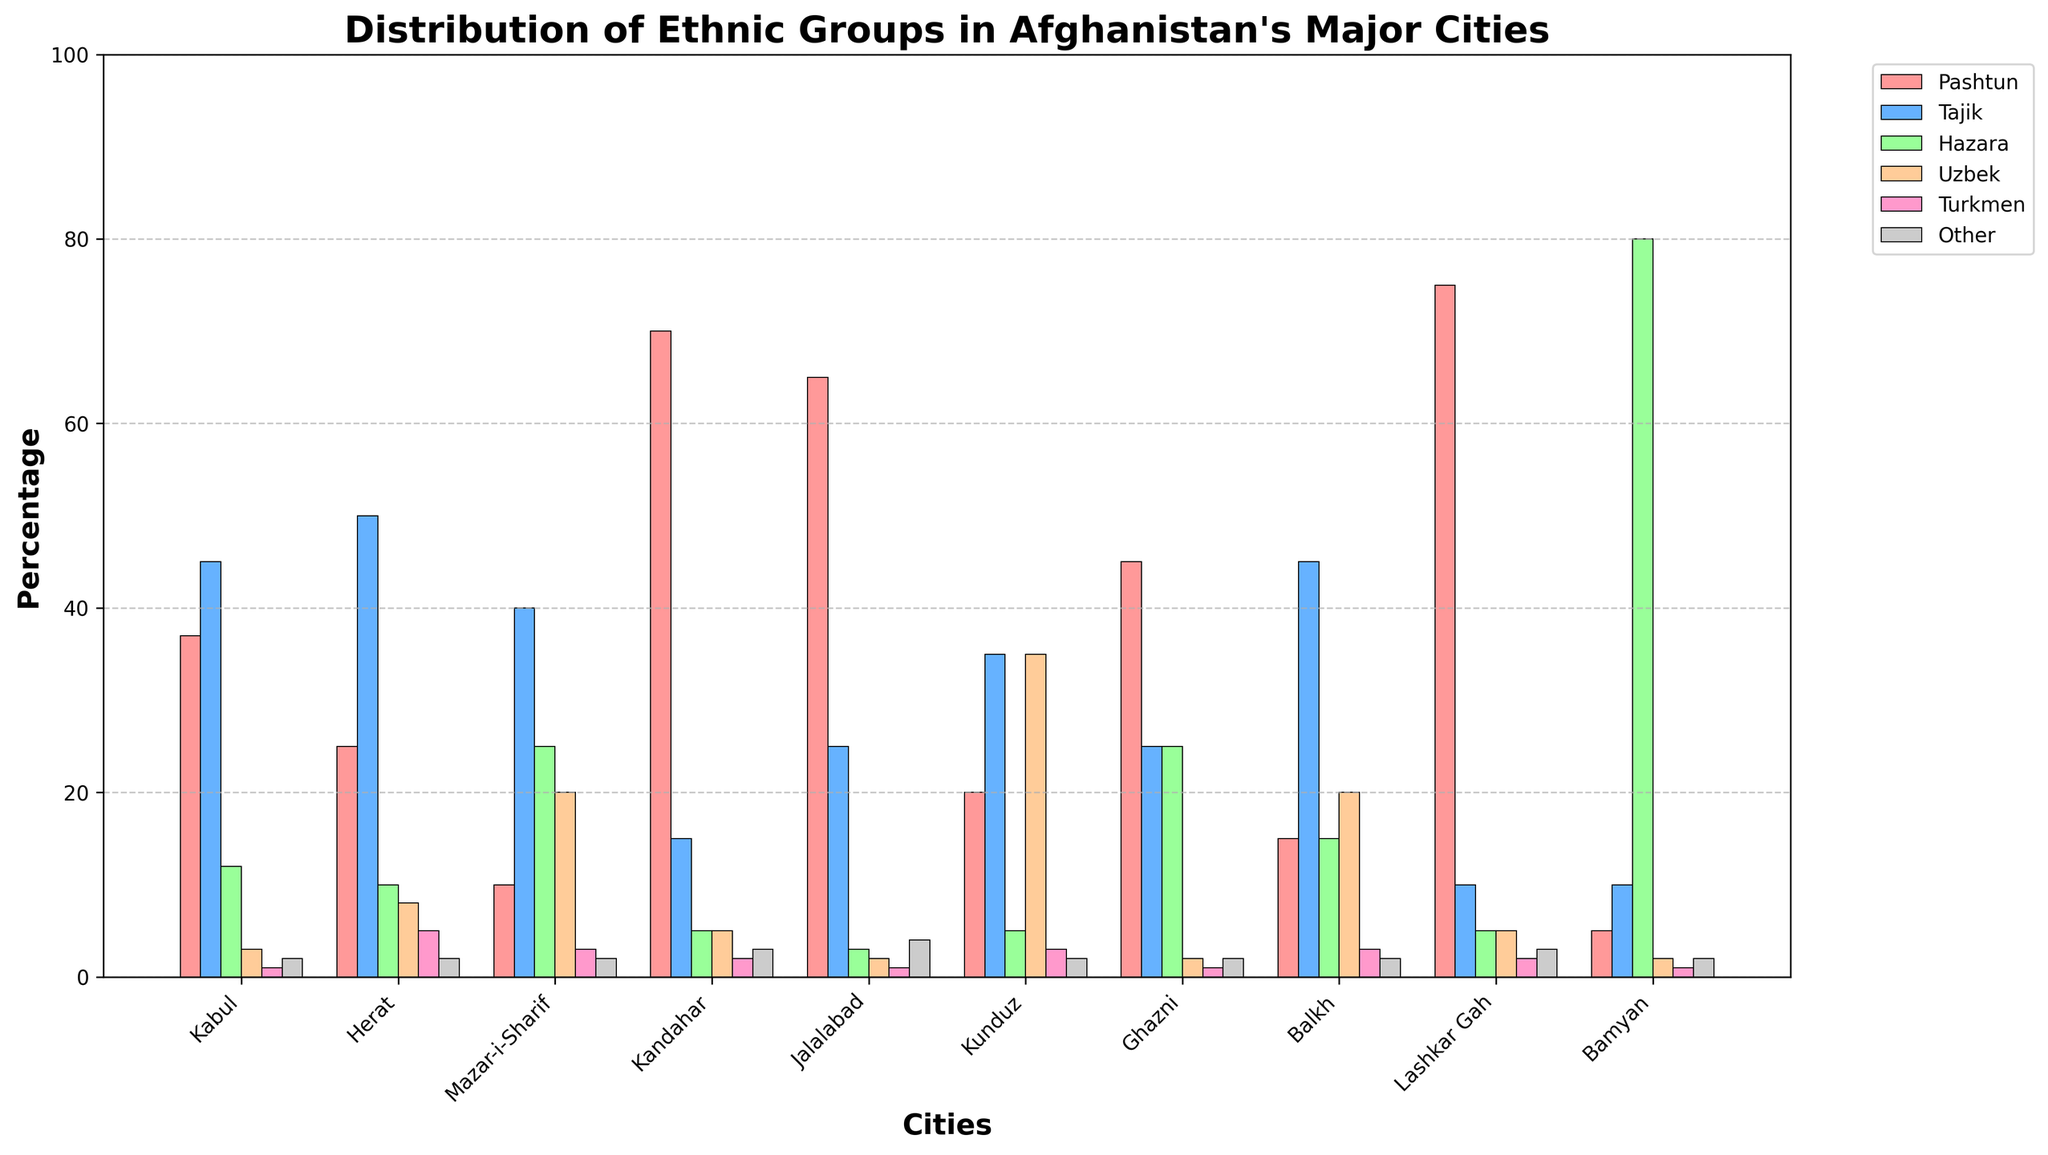What is the largest ethnic group in Kabul? By looking at the chart, the tallest bar for Kabul represents the Tajik ethnic group at 45%.
Answer: Tajik Which city has the highest percentage of Hazaras? The city with the tallest bar for the Hazara group is Bamyan with 80%.
Answer: Bamyan What is the sum of Pashtun percentages in Herat and Kandahar? Pashtuns in Herat account for 25% and in Kandahar for 70%. Summing these gives 25 + 70 = 95.
Answer: 95 In which city are Uzbeks more populous, Mazar-i-Sharif or Kabul? The bar for Uzbeks in Mazar-i-Sharif is taller at 20%, compared to Kabul's 3%.
Answer: Mazar-i-Sharif Are there more Turkmen in Herat or Kunduz? The percentage of Turkmen is equal in both cities with both having 3%.
Answer: Both What is the average percentage of 'Other' ethnic groups across all cities? Sum the percentages of 'Other' for all cities: (2+2+2+3+4+2+2+2+3+2=24). Divide by the number of cities (10). So, 24/10 = 2.4.
Answer: 2.4 Which city's ethnic distribution is dominated by a single ethnic group the most? Lashkar Gah has the most significant single group dominance with Pashtuns making up 75% of the population.
Answer: Lashkar Gah How much more percentage-wise are Pashtuns in Kandahar compared to Kabul? Pashtuns in Kandahar are at 70% and in Kabul at 37%. The difference is 70 - 37 = 33.
Answer: 33 What is the difference between the percentages of Uzbeks in Balkh and Ghazni? Uzbeks in Balkh are at 20% and in Ghazni at 2%. The difference is 20 - 2 = 18.
Answer: 18 Which ethnic group in which city has the lowest representation? Pashtuns in Bamyan have the lowest representation at 5%.
Answer: Pashtuns in Bamyan 